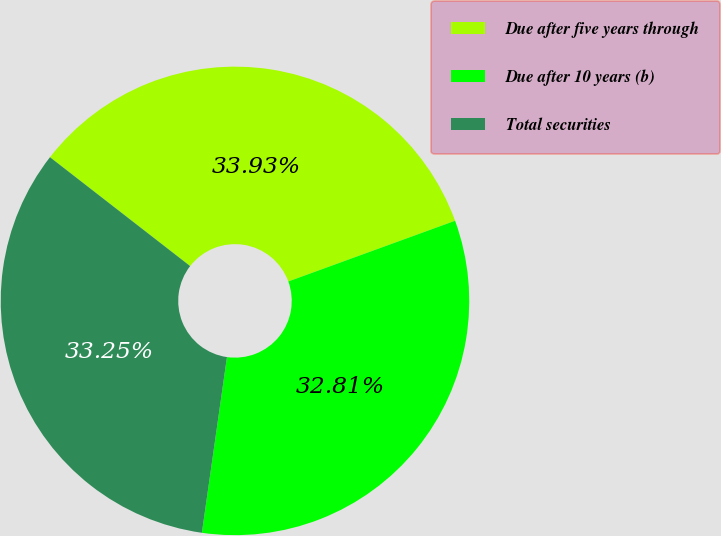Convert chart to OTSL. <chart><loc_0><loc_0><loc_500><loc_500><pie_chart><fcel>Due after five years through<fcel>Due after 10 years (b)<fcel>Total securities<nl><fcel>33.93%<fcel>32.81%<fcel>33.25%<nl></chart> 